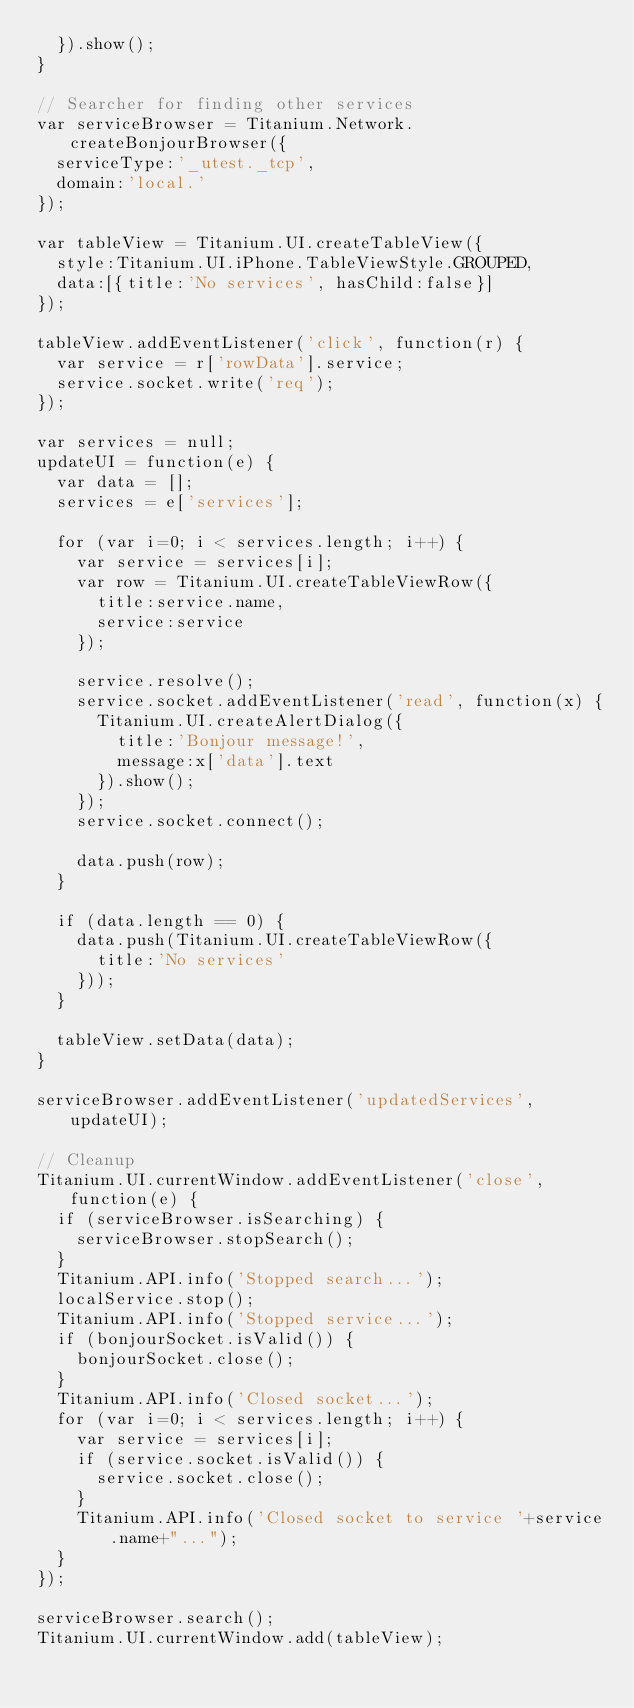<code> <loc_0><loc_0><loc_500><loc_500><_JavaScript_>	}).show();
}

// Searcher for finding other services
var serviceBrowser = Titanium.Network.createBonjourBrowser({
	serviceType:'_utest._tcp',
	domain:'local.'
});

var tableView = Titanium.UI.createTableView({
	style:Titanium.UI.iPhone.TableViewStyle.GROUPED,
	data:[{title:'No services', hasChild:false}]
});

tableView.addEventListener('click', function(r) {
	var service = r['rowData'].service;
	service.socket.write('req');
});

var services = null;
updateUI = function(e) {
	var data = [];
	services = e['services'];
	
	for (var i=0; i < services.length; i++) {
		var service = services[i];
		var row = Titanium.UI.createTableViewRow({
			title:service.name,
			service:service
		});
		
		service.resolve();
		service.socket.addEventListener('read', function(x) {
			Titanium.UI.createAlertDialog({
				title:'Bonjour message!',
				message:x['data'].text
			}).show();
		});
		service.socket.connect();
		
		data.push(row);
	}
	
	if (data.length == 0) {
		data.push(Titanium.UI.createTableViewRow({
			title:'No services'
		}));
	}
	
	tableView.setData(data);
}

serviceBrowser.addEventListener('updatedServices', updateUI);

// Cleanup
Titanium.UI.currentWindow.addEventListener('close', function(e) {
	if (serviceBrowser.isSearching) {
		serviceBrowser.stopSearch();
	}
	Titanium.API.info('Stopped search...');
	localService.stop();
	Titanium.API.info('Stopped service...');
	if (bonjourSocket.isValid()) {
		bonjourSocket.close();
	}
	Titanium.API.info('Closed socket...');
	for (var i=0; i < services.length; i++) {
		var service = services[i];
		if (service.socket.isValid()) {
			service.socket.close();
		}
		Titanium.API.info('Closed socket to service '+service.name+"...");
	}
});

serviceBrowser.search();
Titanium.UI.currentWindow.add(tableView);
</code> 